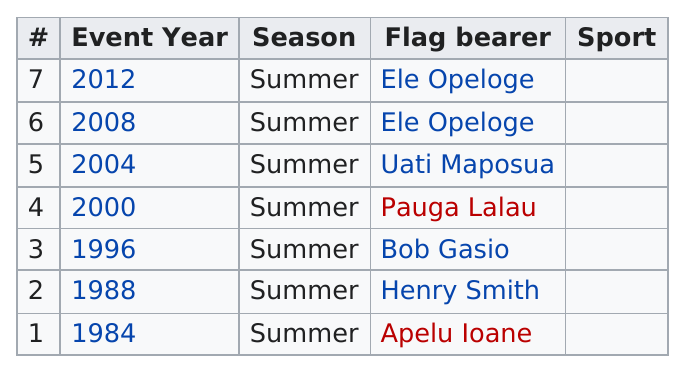Point out several critical features in this image. It is my firm belief that Bob Gasio bore the flag at the Olympics after Henry Smith did so, as there is no evidence to suggest otherwise. Between 2008 and 2012, the Olympic flag was carried by the same person. Ele Opeloge was the athlete who most recently bore the Samoan flag at the Olympic Games. Six people from Samoa have competed at the Olympics. Samoa has been represented at the Summer Olympics for a total of 7 times. 